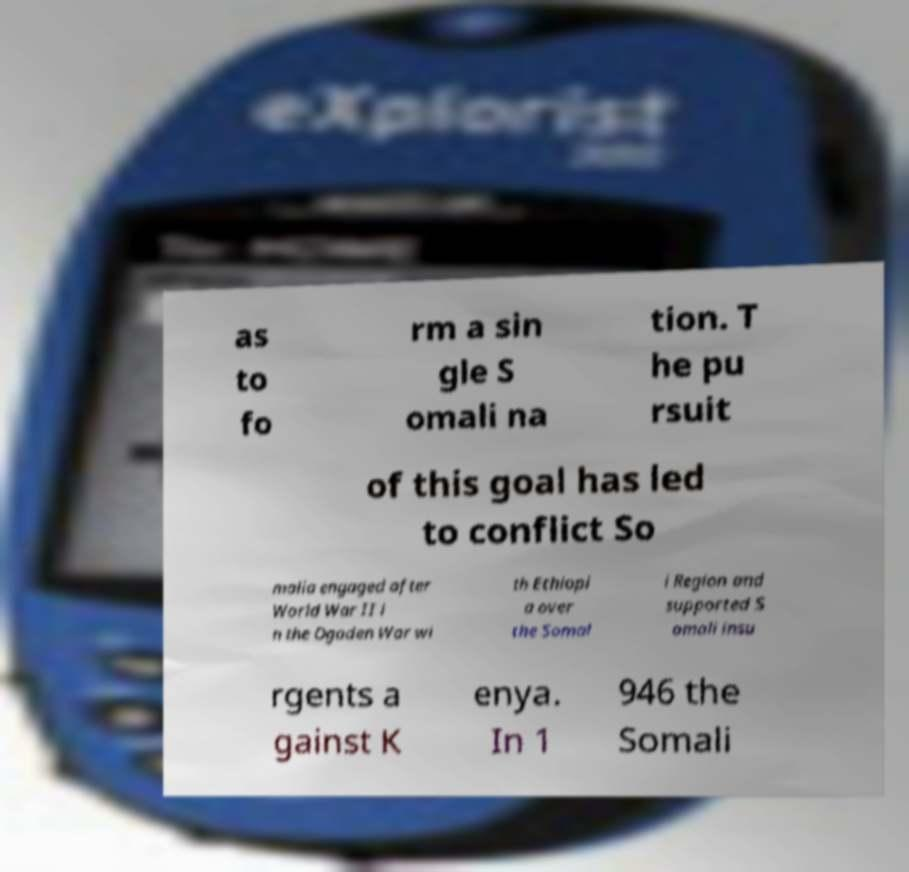Could you extract and type out the text from this image? as to fo rm a sin gle S omali na tion. T he pu rsuit of this goal has led to conflict So malia engaged after World War II i n the Ogaden War wi th Ethiopi a over the Somal i Region and supported S omali insu rgents a gainst K enya. In 1 946 the Somali 